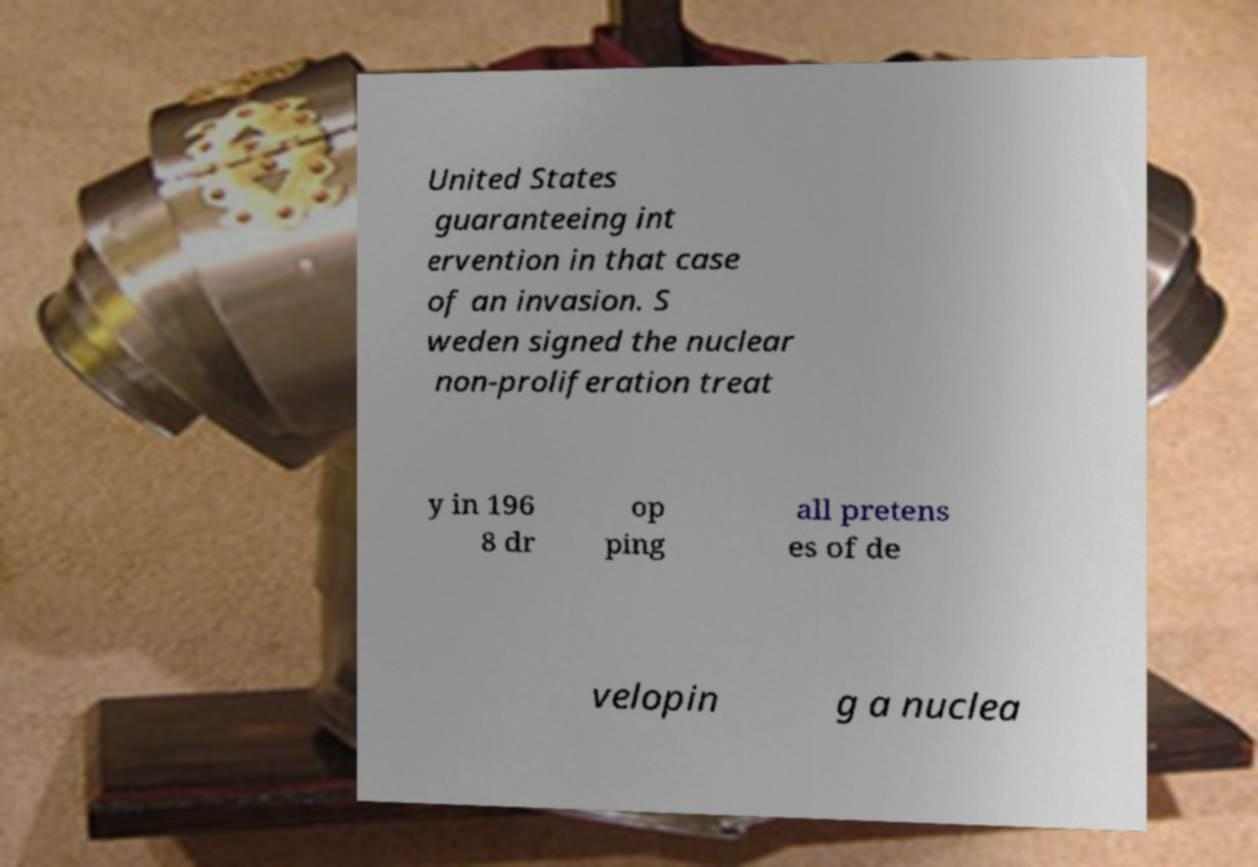Could you extract and type out the text from this image? United States guaranteeing int ervention in that case of an invasion. S weden signed the nuclear non-proliferation treat y in 196 8 dr op ping all pretens es of de velopin g a nuclea 